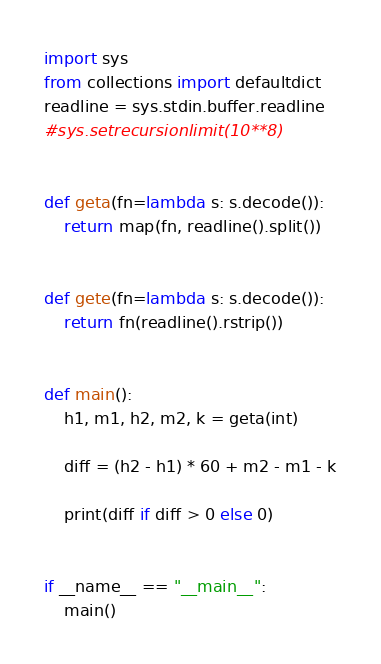<code> <loc_0><loc_0><loc_500><loc_500><_Python_>import sys
from collections import defaultdict
readline = sys.stdin.buffer.readline
#sys.setrecursionlimit(10**8)


def geta(fn=lambda s: s.decode()):
    return map(fn, readline().split())


def gete(fn=lambda s: s.decode()):
    return fn(readline().rstrip())


def main():
    h1, m1, h2, m2, k = geta(int)

    diff = (h2 - h1) * 60 + m2 - m1 - k

    print(diff if diff > 0 else 0)


if __name__ == "__main__":
    main()</code> 